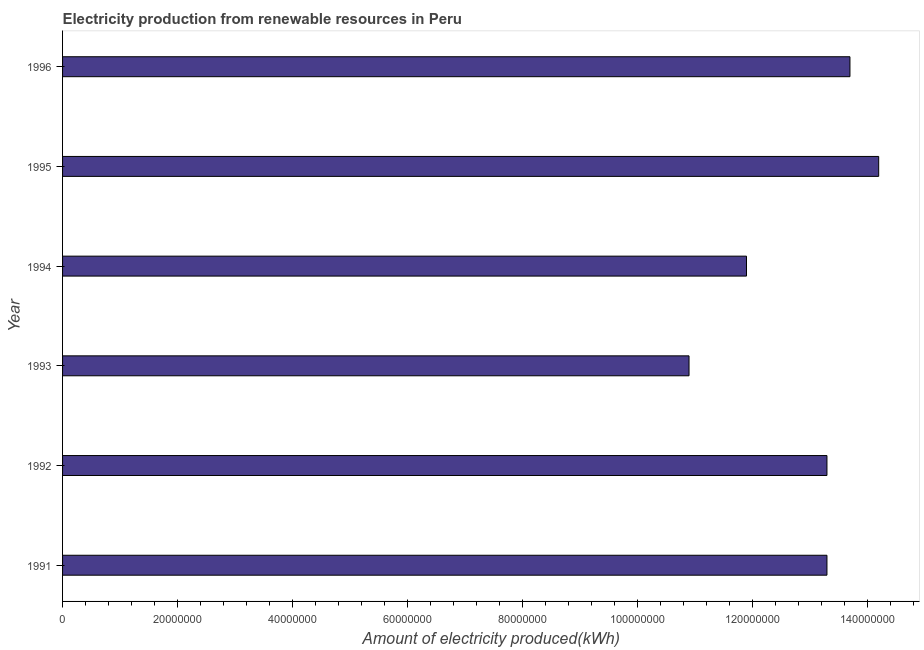Does the graph contain any zero values?
Make the answer very short. No. What is the title of the graph?
Provide a succinct answer. Electricity production from renewable resources in Peru. What is the label or title of the X-axis?
Offer a very short reply. Amount of electricity produced(kWh). What is the label or title of the Y-axis?
Provide a succinct answer. Year. What is the amount of electricity produced in 1993?
Offer a very short reply. 1.09e+08. Across all years, what is the maximum amount of electricity produced?
Provide a succinct answer. 1.42e+08. Across all years, what is the minimum amount of electricity produced?
Your answer should be compact. 1.09e+08. In which year was the amount of electricity produced maximum?
Offer a very short reply. 1995. In which year was the amount of electricity produced minimum?
Offer a very short reply. 1993. What is the sum of the amount of electricity produced?
Your response must be concise. 7.73e+08. What is the difference between the amount of electricity produced in 1991 and 1995?
Provide a short and direct response. -9.00e+06. What is the average amount of electricity produced per year?
Your answer should be compact. 1.29e+08. What is the median amount of electricity produced?
Your answer should be compact. 1.33e+08. In how many years, is the amount of electricity produced greater than 140000000 kWh?
Offer a very short reply. 1. What is the ratio of the amount of electricity produced in 1994 to that in 1995?
Ensure brevity in your answer.  0.84. Is the difference between the amount of electricity produced in 1992 and 1996 greater than the difference between any two years?
Provide a succinct answer. No. What is the difference between the highest and the second highest amount of electricity produced?
Your response must be concise. 5.00e+06. What is the difference between the highest and the lowest amount of electricity produced?
Keep it short and to the point. 3.30e+07. In how many years, is the amount of electricity produced greater than the average amount of electricity produced taken over all years?
Your response must be concise. 4. Are all the bars in the graph horizontal?
Provide a short and direct response. Yes. How many years are there in the graph?
Ensure brevity in your answer.  6. What is the Amount of electricity produced(kWh) of 1991?
Offer a very short reply. 1.33e+08. What is the Amount of electricity produced(kWh) of 1992?
Your answer should be compact. 1.33e+08. What is the Amount of electricity produced(kWh) of 1993?
Your answer should be very brief. 1.09e+08. What is the Amount of electricity produced(kWh) in 1994?
Offer a terse response. 1.19e+08. What is the Amount of electricity produced(kWh) in 1995?
Make the answer very short. 1.42e+08. What is the Amount of electricity produced(kWh) in 1996?
Give a very brief answer. 1.37e+08. What is the difference between the Amount of electricity produced(kWh) in 1991 and 1993?
Ensure brevity in your answer.  2.40e+07. What is the difference between the Amount of electricity produced(kWh) in 1991 and 1994?
Offer a very short reply. 1.40e+07. What is the difference between the Amount of electricity produced(kWh) in 1991 and 1995?
Make the answer very short. -9.00e+06. What is the difference between the Amount of electricity produced(kWh) in 1992 and 1993?
Provide a short and direct response. 2.40e+07. What is the difference between the Amount of electricity produced(kWh) in 1992 and 1994?
Your answer should be very brief. 1.40e+07. What is the difference between the Amount of electricity produced(kWh) in 1992 and 1995?
Make the answer very short. -9.00e+06. What is the difference between the Amount of electricity produced(kWh) in 1992 and 1996?
Ensure brevity in your answer.  -4.00e+06. What is the difference between the Amount of electricity produced(kWh) in 1993 and 1994?
Your response must be concise. -1.00e+07. What is the difference between the Amount of electricity produced(kWh) in 1993 and 1995?
Keep it short and to the point. -3.30e+07. What is the difference between the Amount of electricity produced(kWh) in 1993 and 1996?
Provide a succinct answer. -2.80e+07. What is the difference between the Amount of electricity produced(kWh) in 1994 and 1995?
Provide a succinct answer. -2.30e+07. What is the difference between the Amount of electricity produced(kWh) in 1994 and 1996?
Your answer should be compact. -1.80e+07. What is the difference between the Amount of electricity produced(kWh) in 1995 and 1996?
Keep it short and to the point. 5.00e+06. What is the ratio of the Amount of electricity produced(kWh) in 1991 to that in 1993?
Give a very brief answer. 1.22. What is the ratio of the Amount of electricity produced(kWh) in 1991 to that in 1994?
Offer a very short reply. 1.12. What is the ratio of the Amount of electricity produced(kWh) in 1991 to that in 1995?
Make the answer very short. 0.94. What is the ratio of the Amount of electricity produced(kWh) in 1992 to that in 1993?
Provide a succinct answer. 1.22. What is the ratio of the Amount of electricity produced(kWh) in 1992 to that in 1994?
Ensure brevity in your answer.  1.12. What is the ratio of the Amount of electricity produced(kWh) in 1992 to that in 1995?
Offer a terse response. 0.94. What is the ratio of the Amount of electricity produced(kWh) in 1993 to that in 1994?
Your response must be concise. 0.92. What is the ratio of the Amount of electricity produced(kWh) in 1993 to that in 1995?
Ensure brevity in your answer.  0.77. What is the ratio of the Amount of electricity produced(kWh) in 1993 to that in 1996?
Give a very brief answer. 0.8. What is the ratio of the Amount of electricity produced(kWh) in 1994 to that in 1995?
Offer a very short reply. 0.84. What is the ratio of the Amount of electricity produced(kWh) in 1994 to that in 1996?
Your answer should be compact. 0.87. What is the ratio of the Amount of electricity produced(kWh) in 1995 to that in 1996?
Make the answer very short. 1.04. 